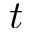Convert formula to latex. <formula><loc_0><loc_0><loc_500><loc_500>t</formula> 